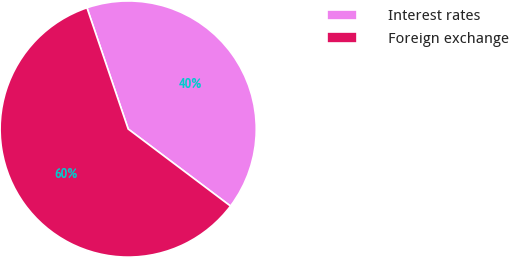<chart> <loc_0><loc_0><loc_500><loc_500><pie_chart><fcel>Interest rates<fcel>Foreign exchange<nl><fcel>40.49%<fcel>59.51%<nl></chart> 